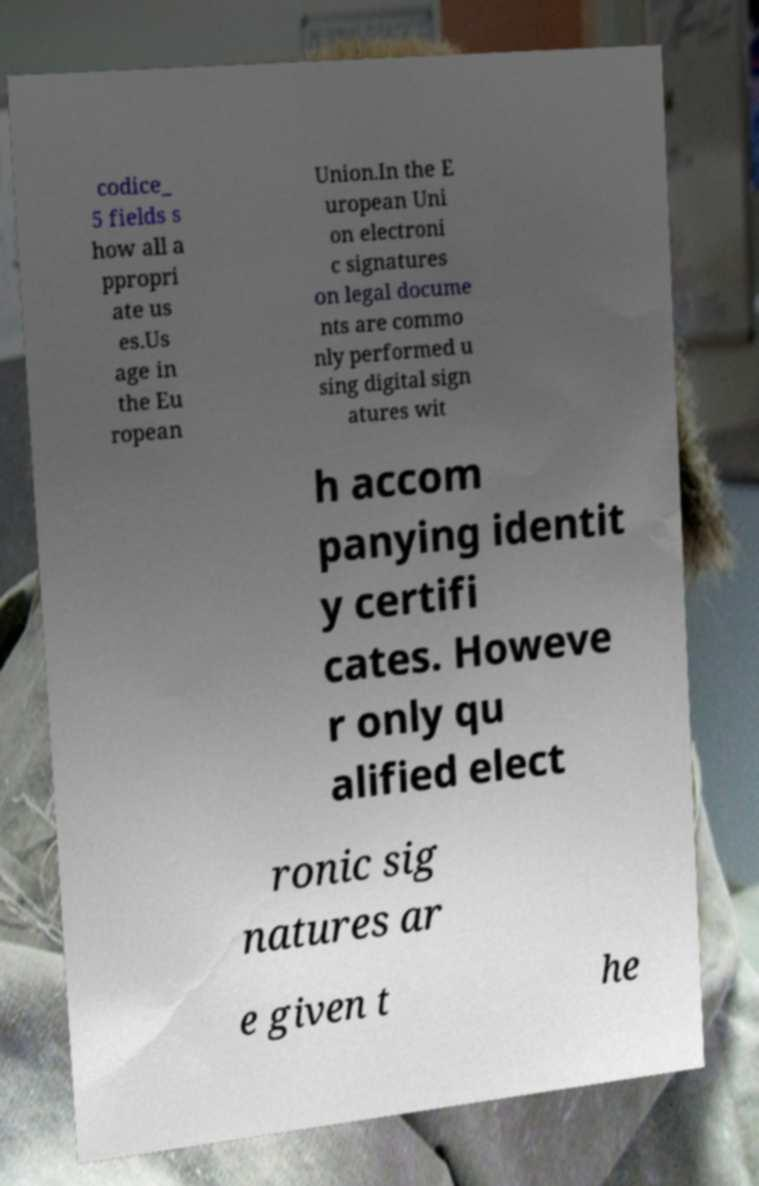I need the written content from this picture converted into text. Can you do that? codice_ 5 fields s how all a ppropri ate us es.Us age in the Eu ropean Union.In the E uropean Uni on electroni c signatures on legal docume nts are commo nly performed u sing digital sign atures wit h accom panying identit y certifi cates. Howeve r only qu alified elect ronic sig natures ar e given t he 